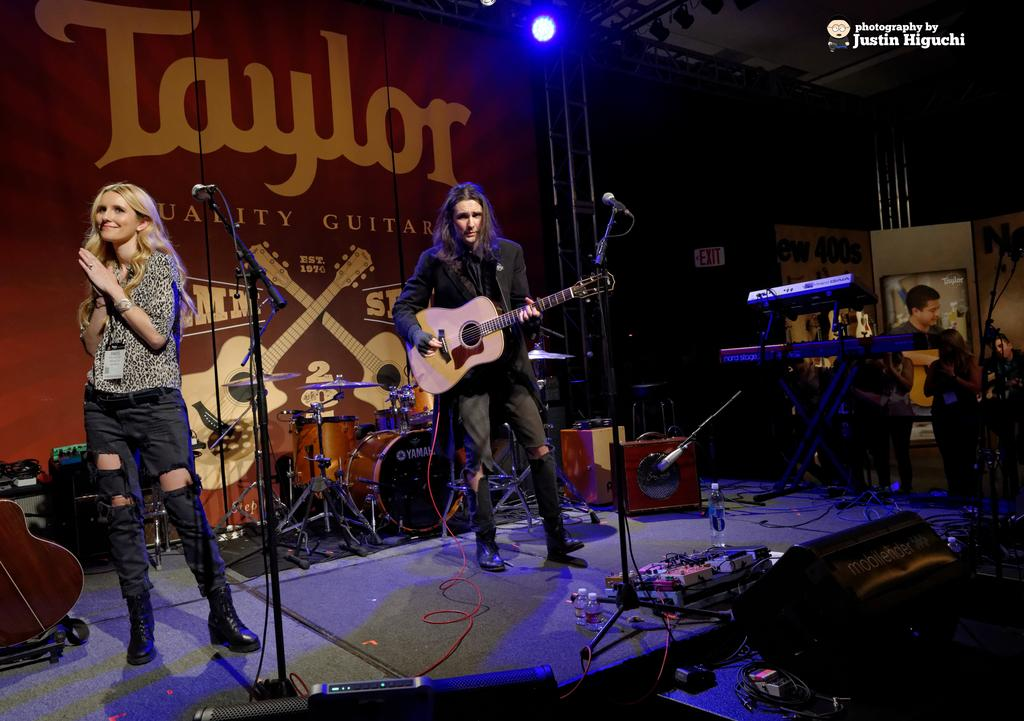What is the man in the image doing? The man is standing and holding a guitar. What is the woman in the image doing? The woman is standing in front of a microphone with a stand. Can you describe the man's and woman's positions in relation to each other? The man and woman are both standing, but it is not clear if they are facing each other or not. What type of question is the man asking the woman in the image? There is no indication in the image that the man is asking the woman a question. 